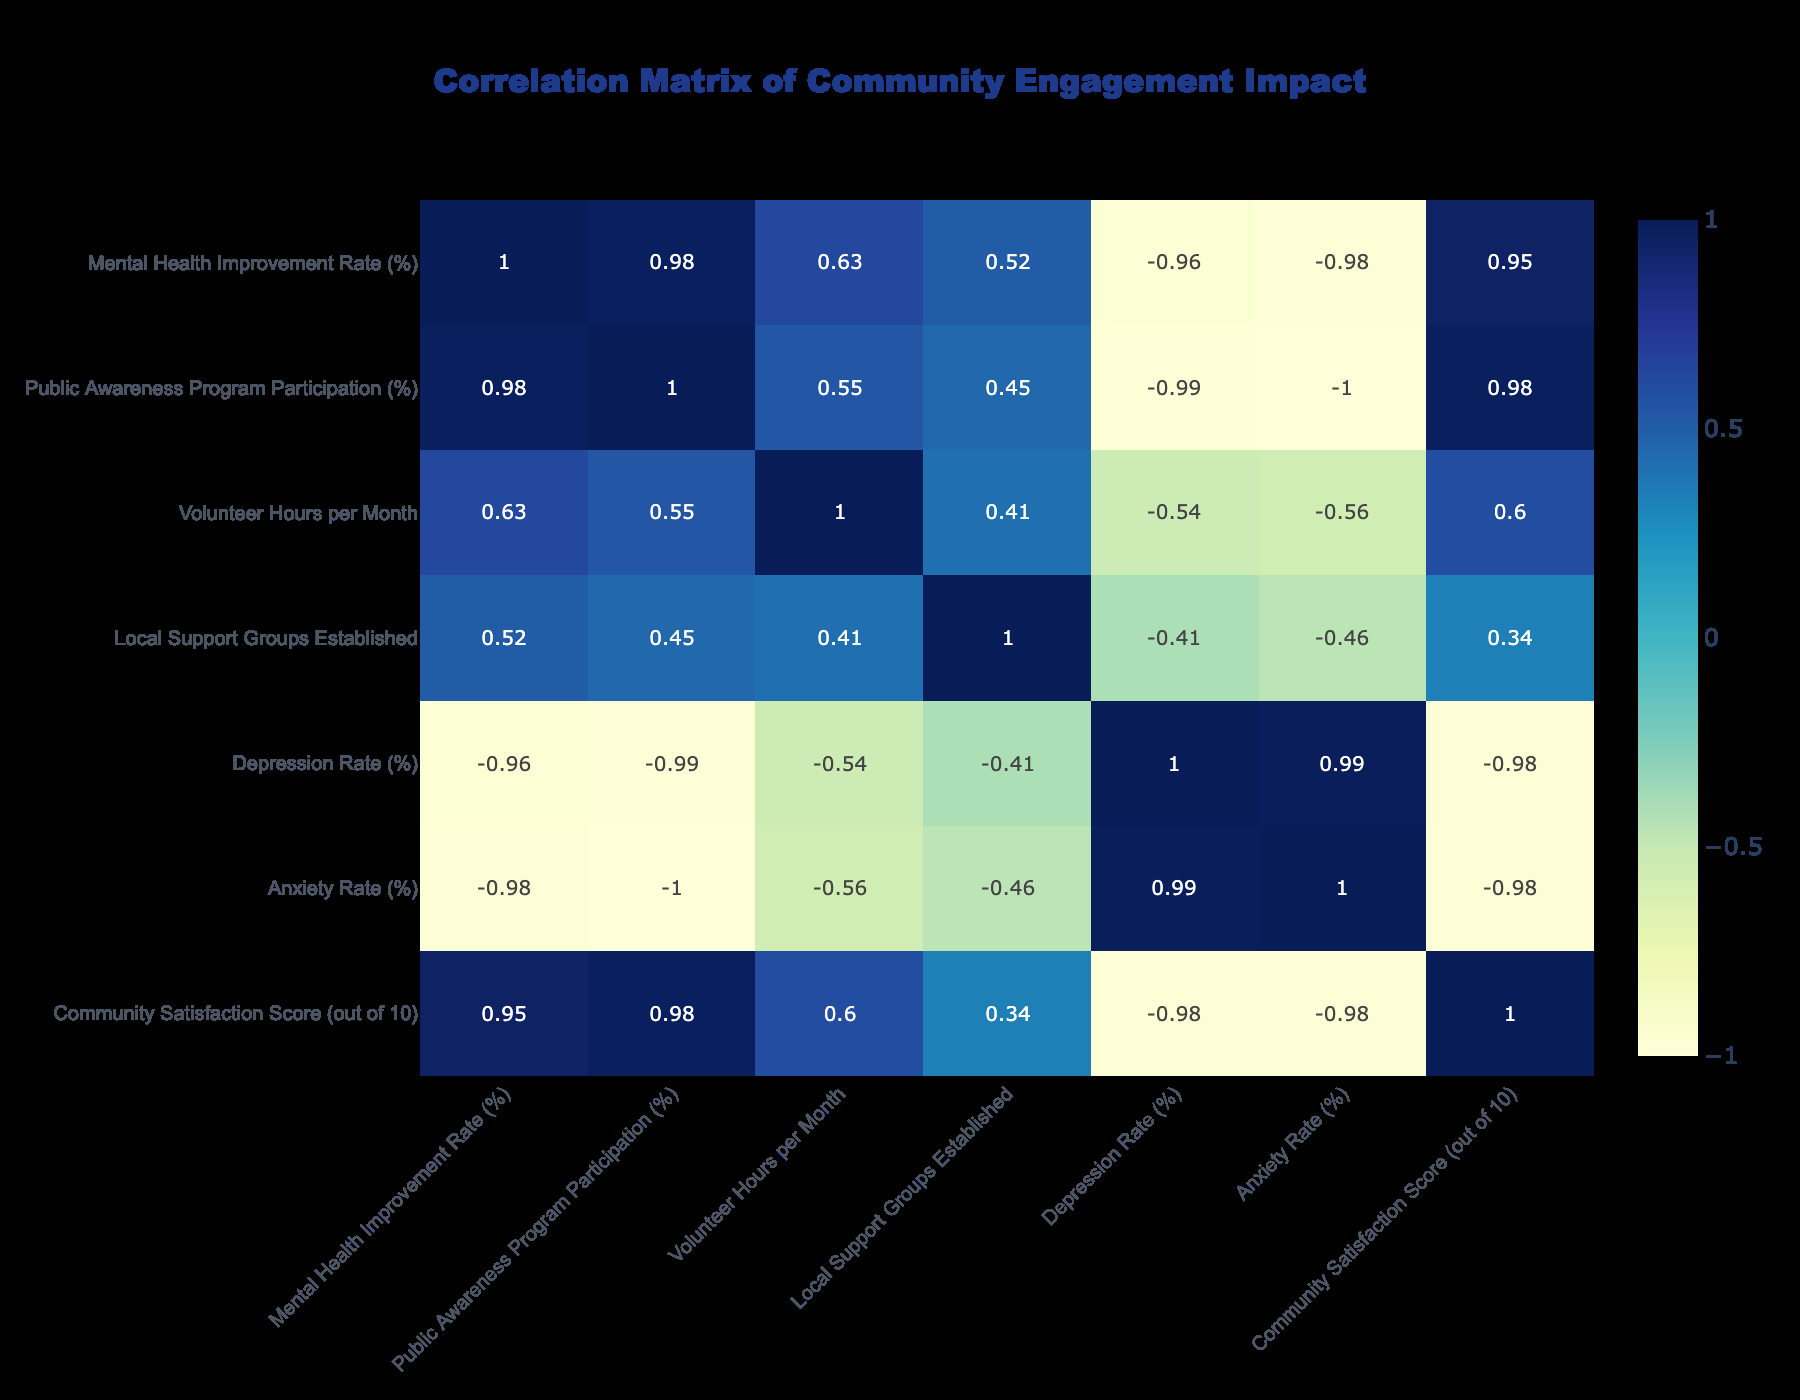What is the mental health improvement rate for the Mental Health Awareness Month Activities? The mental health improvement rate is reported directly in the table. For the Mental Health Awareness Month Activities, it is 60%.
Answer: 60% Which community engagement activity has the highest depression rate? The depression rate is a column in the table. Comparing the rates, the Senior Social Club has the highest depression rate at 18%.
Answer: 18% What is the average community satisfaction score across all activities listed? To find the average community satisfaction score, we sum all scores (8.5 + 7.8 + 9.0 + 8.9 + 7.5 + 9.5 + 9.3 + 9.8) which equals 70.3. There are 8 activities, so we divide 70.3 by 8, resulting in an average of 8.7875, which can be rounded to 8.79.
Answer: 8.79 Does participating in Public Awareness Programs correlate positively with Community Satisfaction? We look at the correlation value between Public Awareness Program Participation and Community Satisfaction Score in the correlation table. A positive correlation means the value is greater than 0. Since the value is positive, it indicates a positive correlation.
Answer: Yes Which activity has the most volunteer hours per month, and how does it relate to the mental health improvement rate? The Fitness and Wellness Fair has the highest volunteer hours at 150. The mental health improvement rate for this activity is 45%. There is a connection between higher volunteer hours and improvement rates, suggesting they could be correlated but requires further analysis.
Answer: Fitness and Wellness Fair, 45% improvement rate 